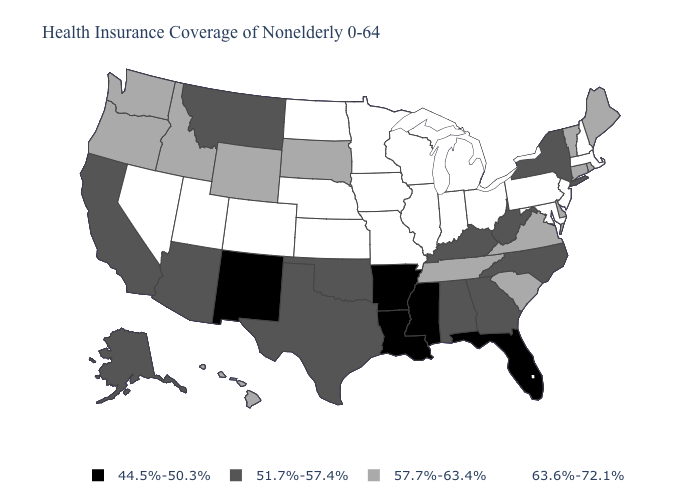What is the value of Arkansas?
Write a very short answer. 44.5%-50.3%. What is the value of Kentucky?
Give a very brief answer. 51.7%-57.4%. What is the lowest value in the USA?
Be succinct. 44.5%-50.3%. Which states hav the highest value in the West?
Give a very brief answer. Colorado, Nevada, Utah. Name the states that have a value in the range 57.7%-63.4%?
Be succinct. Connecticut, Delaware, Hawaii, Idaho, Maine, Oregon, Rhode Island, South Carolina, South Dakota, Tennessee, Vermont, Virginia, Washington, Wyoming. Name the states that have a value in the range 44.5%-50.3%?
Answer briefly. Arkansas, Florida, Louisiana, Mississippi, New Mexico. Which states hav the highest value in the MidWest?
Concise answer only. Illinois, Indiana, Iowa, Kansas, Michigan, Minnesota, Missouri, Nebraska, North Dakota, Ohio, Wisconsin. Which states have the lowest value in the South?
Be succinct. Arkansas, Florida, Louisiana, Mississippi. Among the states that border Nebraska , does Kansas have the highest value?
Answer briefly. Yes. Name the states that have a value in the range 63.6%-72.1%?
Keep it brief. Colorado, Illinois, Indiana, Iowa, Kansas, Maryland, Massachusetts, Michigan, Minnesota, Missouri, Nebraska, Nevada, New Hampshire, New Jersey, North Dakota, Ohio, Pennsylvania, Utah, Wisconsin. Name the states that have a value in the range 63.6%-72.1%?
Quick response, please. Colorado, Illinois, Indiana, Iowa, Kansas, Maryland, Massachusetts, Michigan, Minnesota, Missouri, Nebraska, Nevada, New Hampshire, New Jersey, North Dakota, Ohio, Pennsylvania, Utah, Wisconsin. Does Montana have the same value as Georgia?
Concise answer only. Yes. Which states have the highest value in the USA?
Short answer required. Colorado, Illinois, Indiana, Iowa, Kansas, Maryland, Massachusetts, Michigan, Minnesota, Missouri, Nebraska, Nevada, New Hampshire, New Jersey, North Dakota, Ohio, Pennsylvania, Utah, Wisconsin. What is the highest value in the USA?
Be succinct. 63.6%-72.1%. What is the lowest value in the USA?
Short answer required. 44.5%-50.3%. 